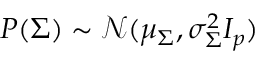<formula> <loc_0><loc_0><loc_500><loc_500>P ( \Sigma ) \sim \mathcal { N } ( \mu _ { \Sigma } , \sigma _ { \Sigma } ^ { 2 } I _ { p } )</formula> 